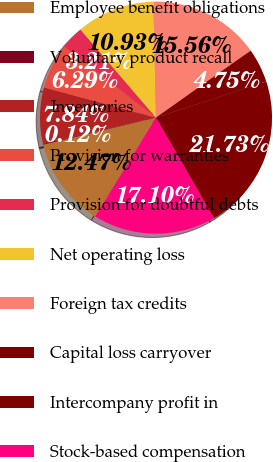Convert chart to OTSL. <chart><loc_0><loc_0><loc_500><loc_500><pie_chart><fcel>Employee benefit obligations<fcel>Voluntary product recall<fcel>Inventories<fcel>Provision for warranties<fcel>Provision for doubtful debts<fcel>Net operating loss<fcel>Foreign tax credits<fcel>Capital loss carryover<fcel>Intercompany profit in<fcel>Stock-based compensation<nl><fcel>12.47%<fcel>0.12%<fcel>7.84%<fcel>6.29%<fcel>3.21%<fcel>10.93%<fcel>15.56%<fcel>4.75%<fcel>21.73%<fcel>17.1%<nl></chart> 